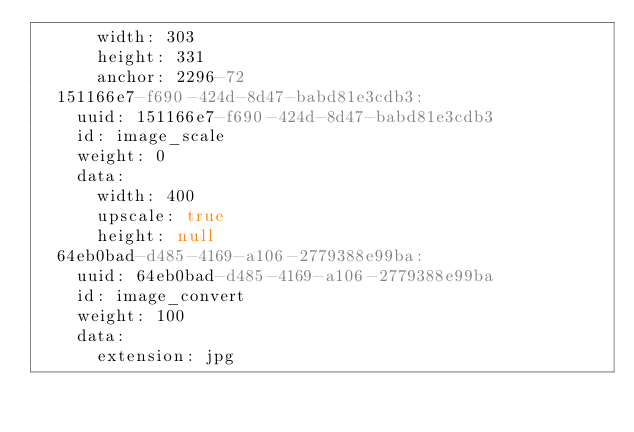Convert code to text. <code><loc_0><loc_0><loc_500><loc_500><_YAML_>      width: 303
      height: 331
      anchor: 2296-72
  151166e7-f690-424d-8d47-babd81e3cdb3:
    uuid: 151166e7-f690-424d-8d47-babd81e3cdb3
    id: image_scale
    weight: 0
    data:
      width: 400
      upscale: true
      height: null
  64eb0bad-d485-4169-a106-2779388e99ba:
    uuid: 64eb0bad-d485-4169-a106-2779388e99ba
    id: image_convert
    weight: 100
    data:
      extension: jpg
</code> 